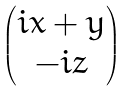<formula> <loc_0><loc_0><loc_500><loc_500>\begin{pmatrix} i x + y \\ - i z \end{pmatrix}</formula> 